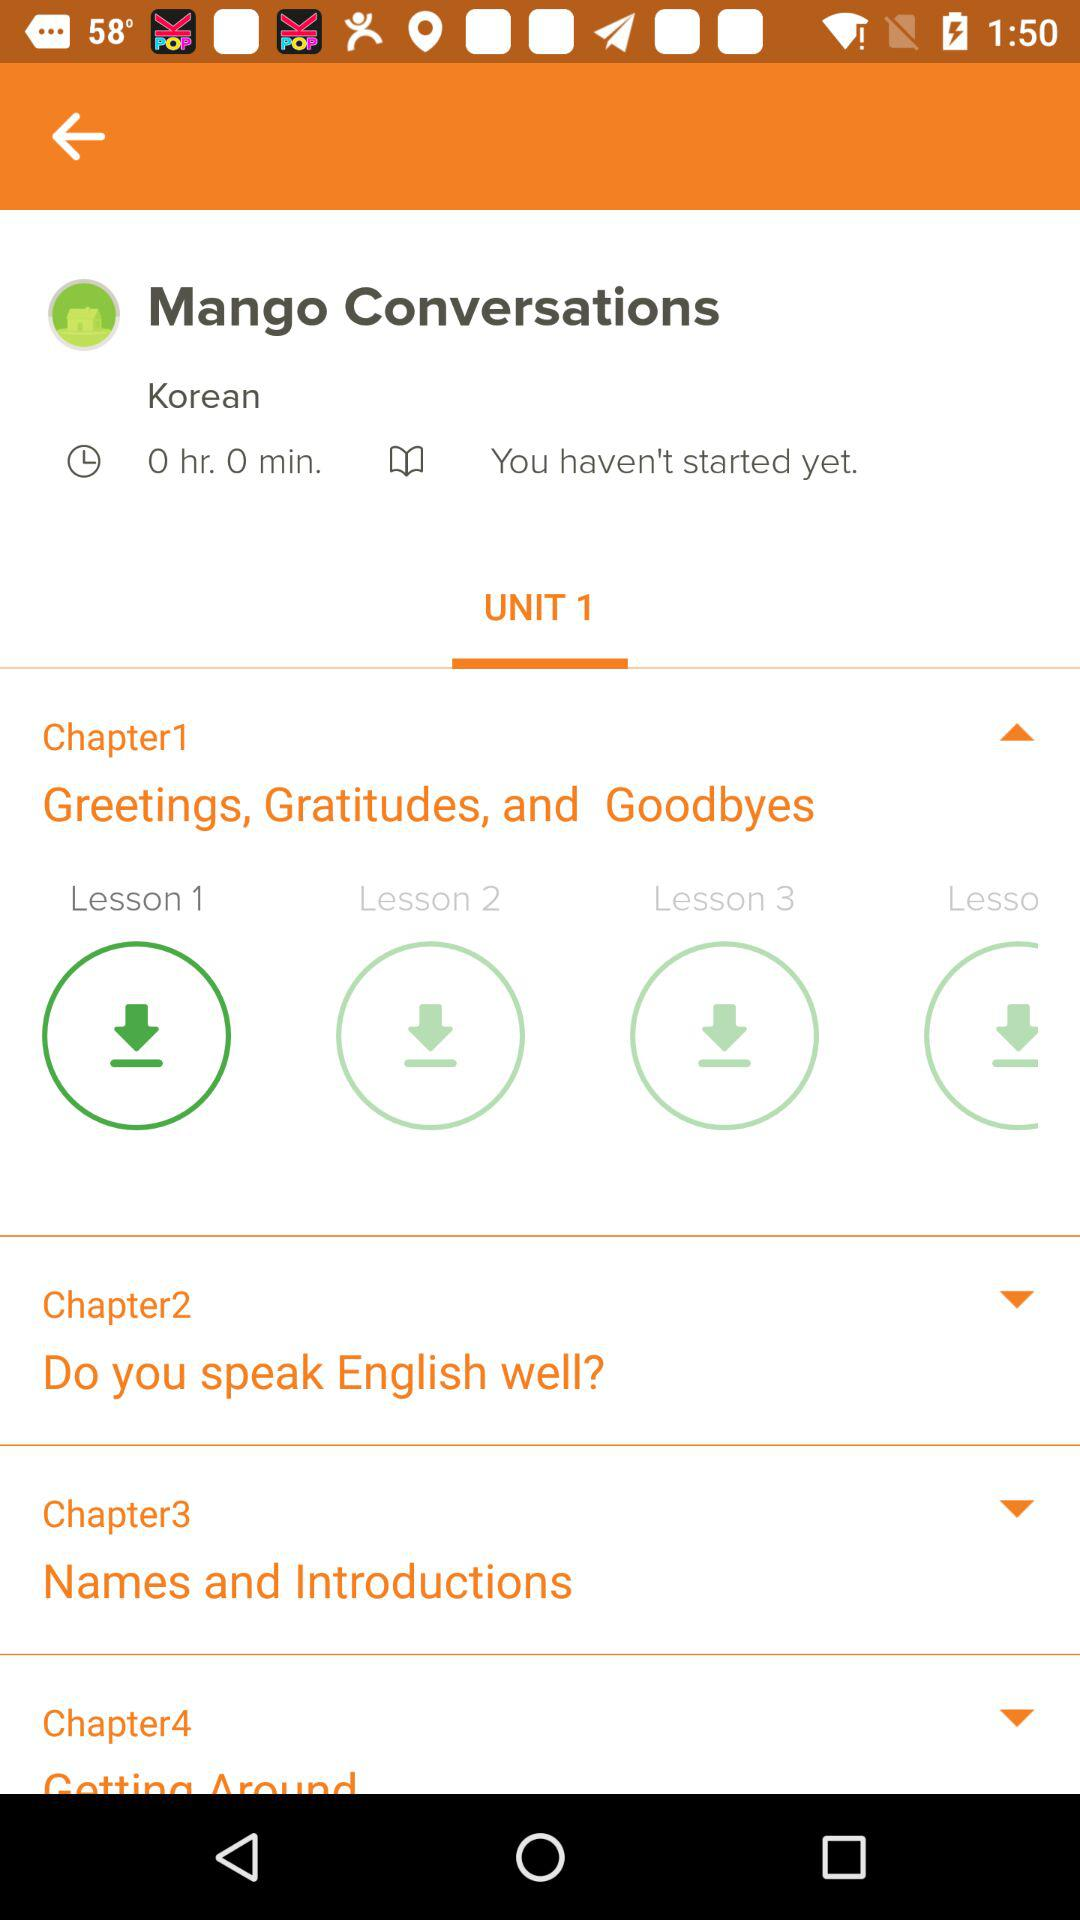What is the name of Chapter 1? The name of Chapter 1 is "Greetings, Gratitudes, and Goodbyes". 